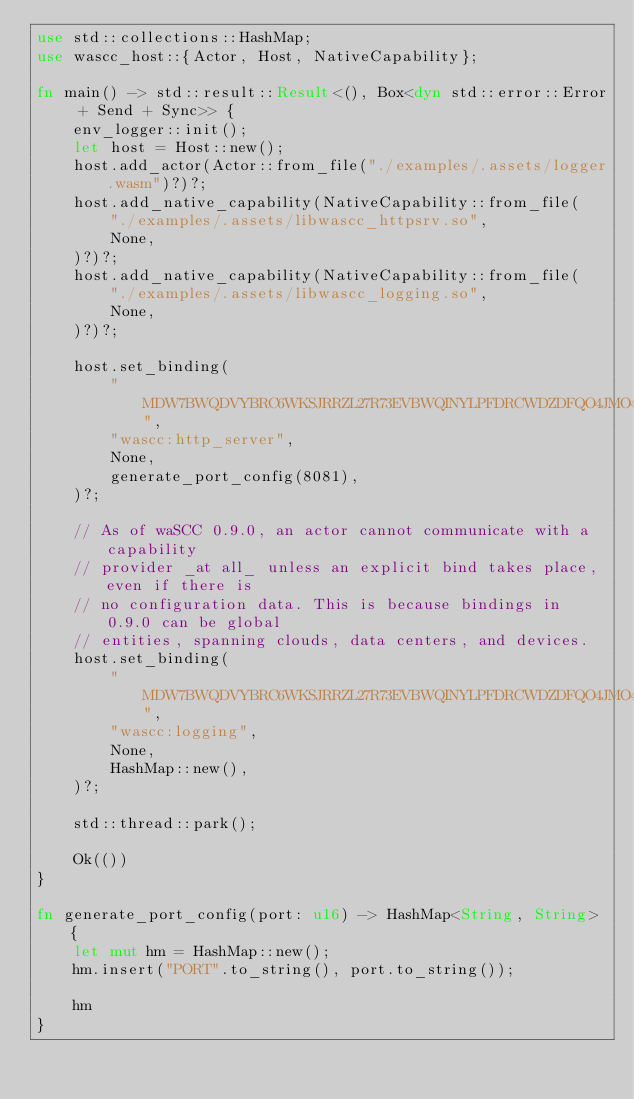<code> <loc_0><loc_0><loc_500><loc_500><_Rust_>use std::collections::HashMap;
use wascc_host::{Actor, Host, NativeCapability};

fn main() -> std::result::Result<(), Box<dyn std::error::Error + Send + Sync>> {
    env_logger::init();
    let host = Host::new();
    host.add_actor(Actor::from_file("./examples/.assets/logger.wasm")?)?;
    host.add_native_capability(NativeCapability::from_file(
        "./examples/.assets/libwascc_httpsrv.so",
        None,
    )?)?;
    host.add_native_capability(NativeCapability::from_file(
        "./examples/.assets/libwascc_logging.so",
        None,
    )?)?;

    host.set_binding(
        "MDW7BWQDVYBRC6WKSJRRZL27R73EVBWQINYLPFDRCWDZDFQO4JMO4U6J",
        "wascc:http_server",
        None,
        generate_port_config(8081),
    )?;

    // As of waSCC 0.9.0, an actor cannot communicate with a capability
    // provider _at all_ unless an explicit bind takes place, even if there is
    // no configuration data. This is because bindings in 0.9.0 can be global
    // entities, spanning clouds, data centers, and devices.
    host.set_binding(
        "MDW7BWQDVYBRC6WKSJRRZL27R73EVBWQINYLPFDRCWDZDFQO4JMO4U6J",
        "wascc:logging",
        None,
        HashMap::new(),
    )?;

    std::thread::park();

    Ok(())
}

fn generate_port_config(port: u16) -> HashMap<String, String> {
    let mut hm = HashMap::new();
    hm.insert("PORT".to_string(), port.to_string());

    hm
}
</code> 